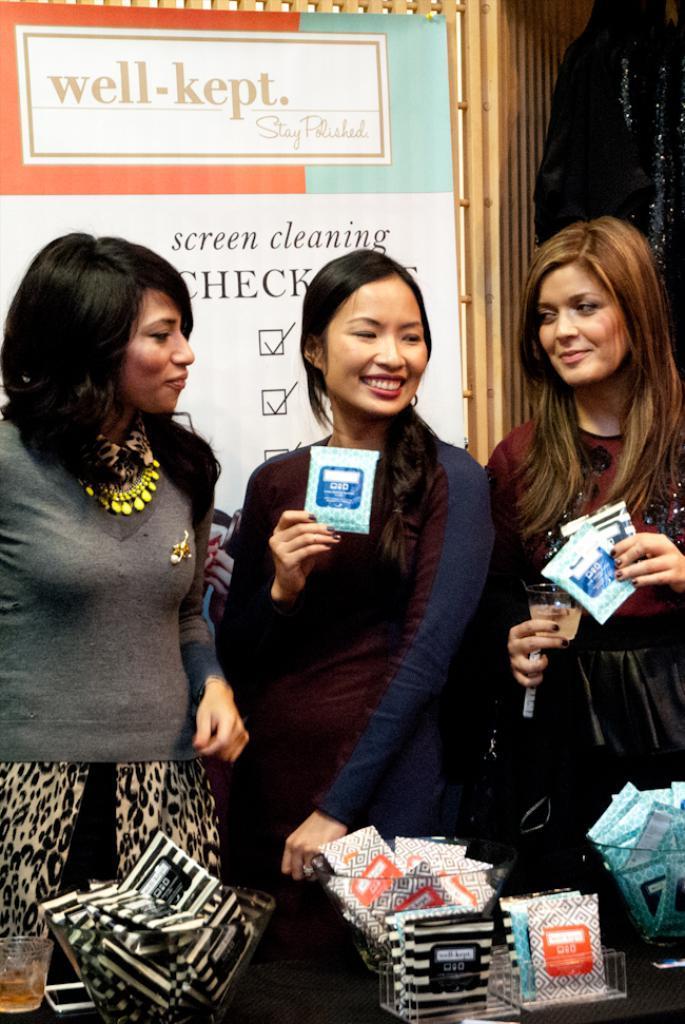In one or two sentences, can you explain what this image depicts? In this image I see 3 women in which these both of them are smiling and I see that they're holding few things in their hands and I see few more things over here and I see a glass over here. In the background I see something is written over here and I see the black color thing over here. 